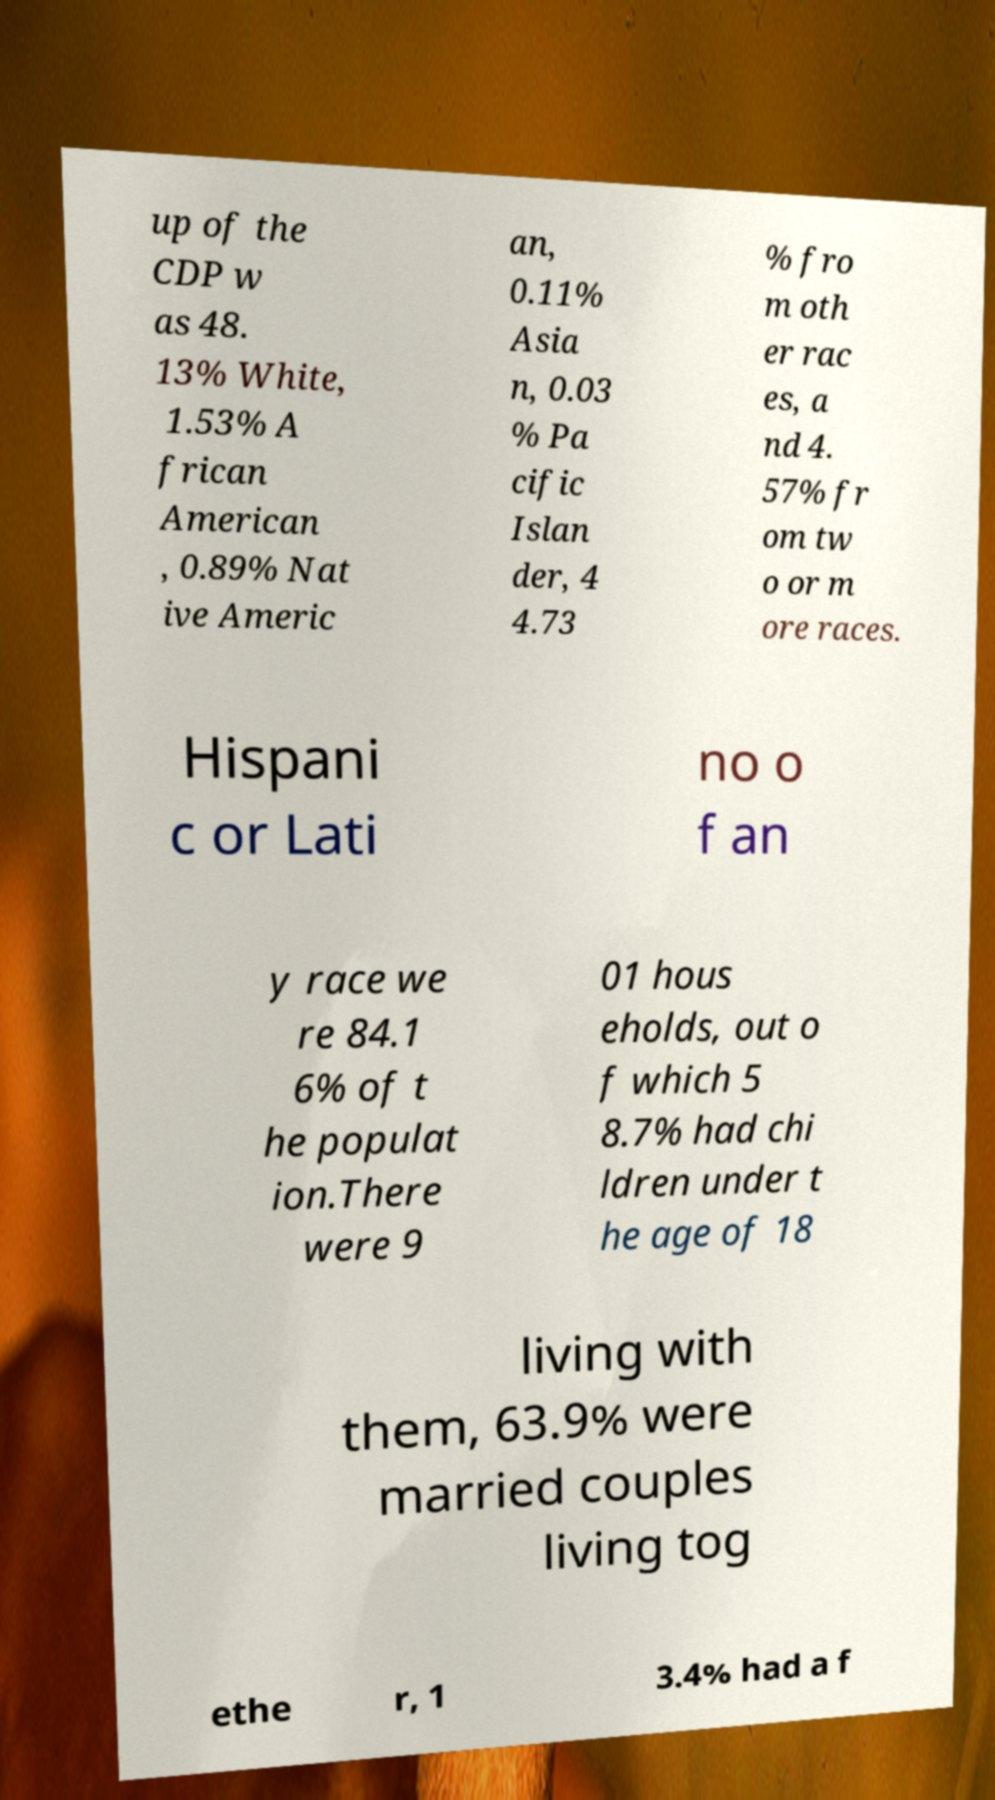What messages or text are displayed in this image? I need them in a readable, typed format. up of the CDP w as 48. 13% White, 1.53% A frican American , 0.89% Nat ive Americ an, 0.11% Asia n, 0.03 % Pa cific Islan der, 4 4.73 % fro m oth er rac es, a nd 4. 57% fr om tw o or m ore races. Hispani c or Lati no o f an y race we re 84.1 6% of t he populat ion.There were 9 01 hous eholds, out o f which 5 8.7% had chi ldren under t he age of 18 living with them, 63.9% were married couples living tog ethe r, 1 3.4% had a f 